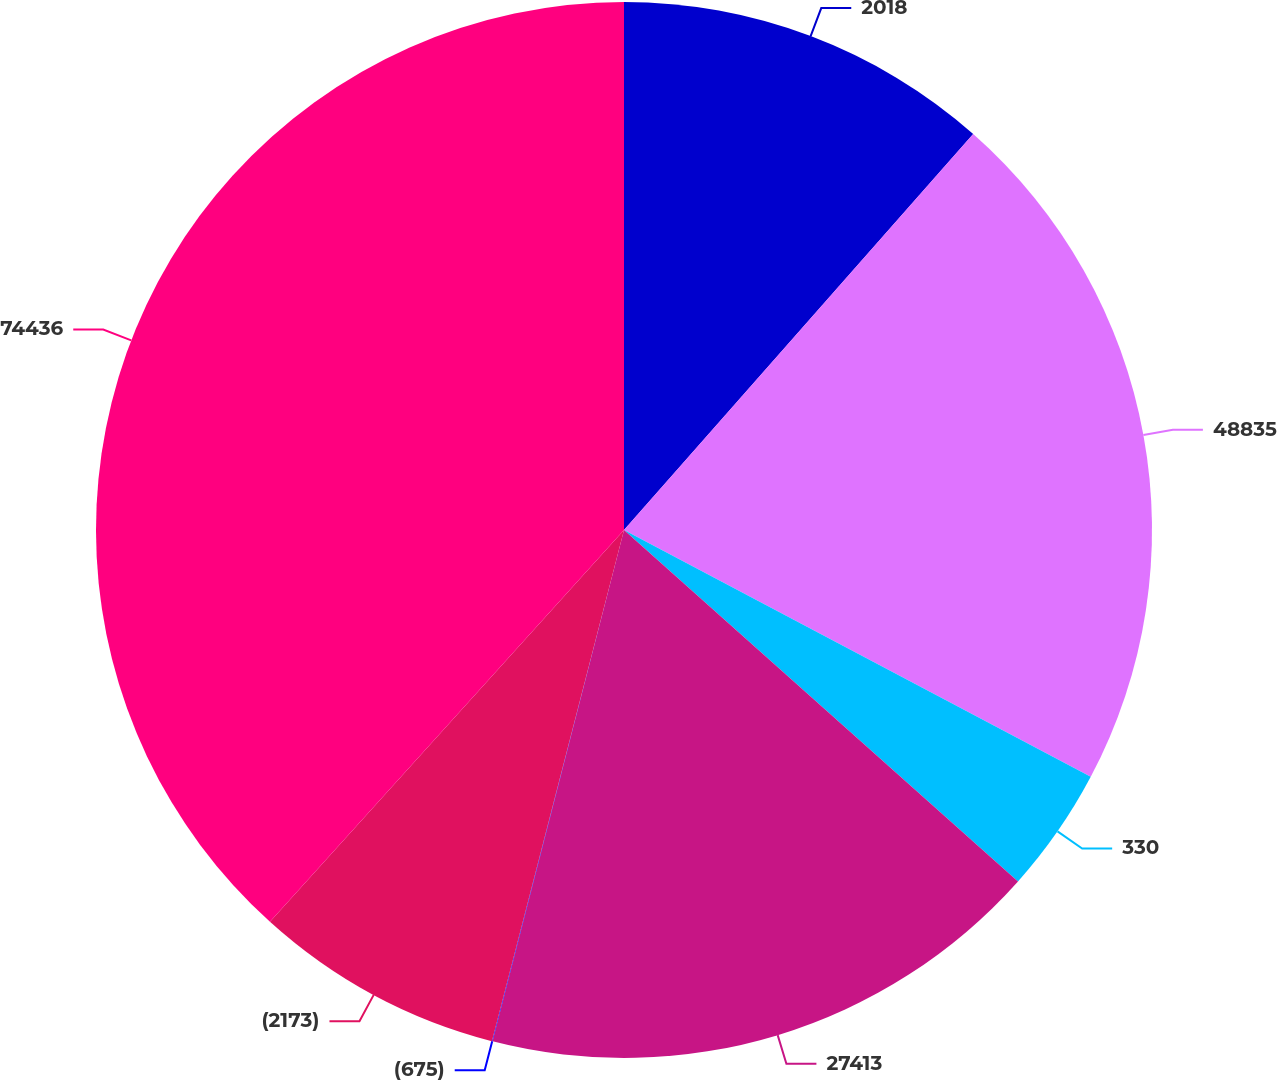Convert chart to OTSL. <chart><loc_0><loc_0><loc_500><loc_500><pie_chart><fcel>2018<fcel>48835<fcel>330<fcel>27413<fcel>(675)<fcel>(2173)<fcel>74436<nl><fcel>11.5%<fcel>21.24%<fcel>3.85%<fcel>17.41%<fcel>0.02%<fcel>7.67%<fcel>38.3%<nl></chart> 